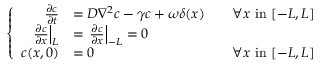Convert formula to latex. <formula><loc_0><loc_0><loc_500><loc_500>\left \{ \begin{array} { r l r } { \frac { \partial c } { \partial t } } & { = D \nabla ^ { 2 } c - \gamma c + \omega \delta ( x ) } & { \quad \forall x i n [ - L , L ] } \\ { \frac { \partial c } { \partial x } \right | _ { L } } & { = \frac { \partial c } { \partial x } \right | _ { - L } = 0 } \\ { c ( x , 0 ) } & { = 0 } & { \forall x i n [ - L , L ] } \end{array}</formula> 